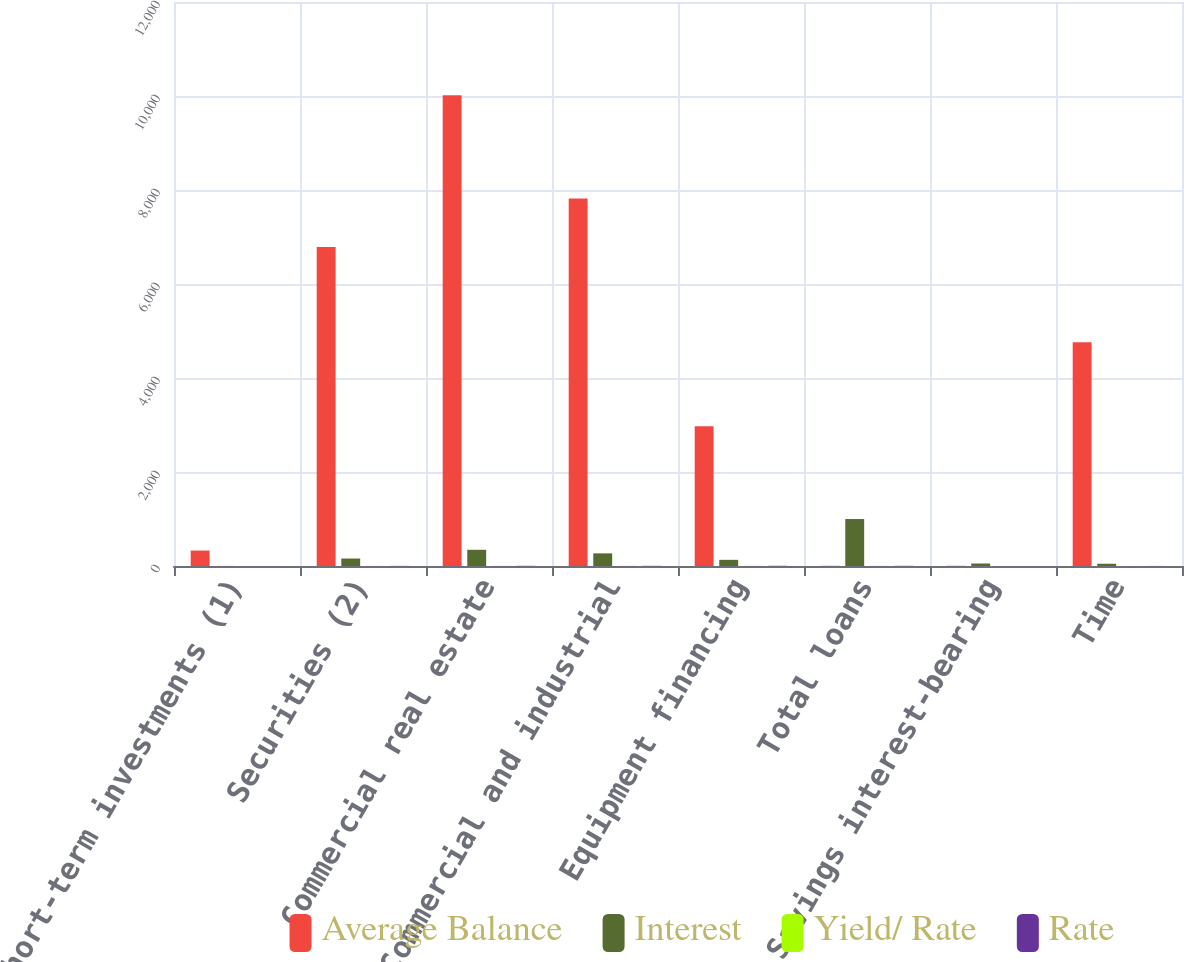<chart> <loc_0><loc_0><loc_500><loc_500><stacked_bar_chart><ecel><fcel>Short-term investments (1)<fcel>Securities (2)<fcel>Commercial real estate<fcel>Commercial and industrial<fcel>Equipment financing<fcel>Total loans<fcel>Savings interest-bearing<fcel>Time<nl><fcel>Average Balance<fcel>328.7<fcel>6786.7<fcel>10013.3<fcel>7821.8<fcel>2972.3<fcel>4.135<fcel>4.135<fcel>4760.4<nl><fcel>Interest<fcel>1.5<fcel>158.8<fcel>344.6<fcel>268.8<fcel>130.9<fcel>999.3<fcel>53<fcel>47.9<nl><fcel>Yield/ Rate<fcel>0.45<fcel>2.34<fcel>3.44<fcel>3.44<fcel>4.4<fcel>3.47<fcel>0.29<fcel>1.01<nl><fcel>Rate<fcel>0.2<fcel>2.24<fcel>3.87<fcel>3.57<fcel>4.69<fcel>3.74<fcel>0.26<fcel>0.95<nl></chart> 